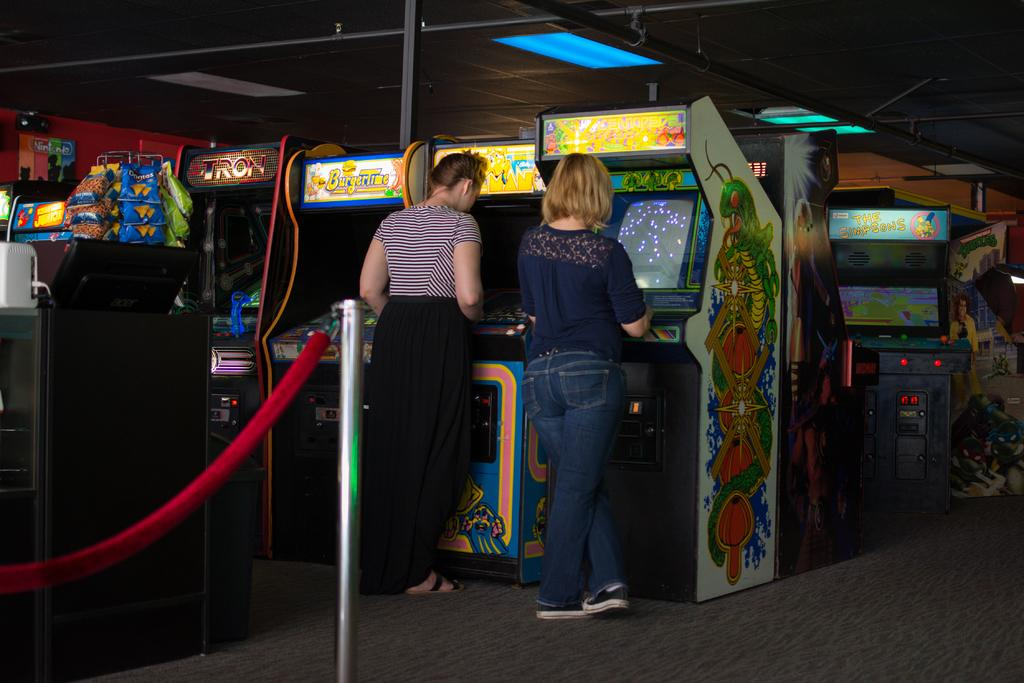How many people are present in the image? There are two persons standing in the image. What can be seen in the background of the image? There are arcade machines in the background of the image. What is visible at the bottom of the image? There is a floor visible at the bottom of the image. What type of chess pieces can be seen on the floor in the image? There are no chess pieces visible on the floor in the image. 